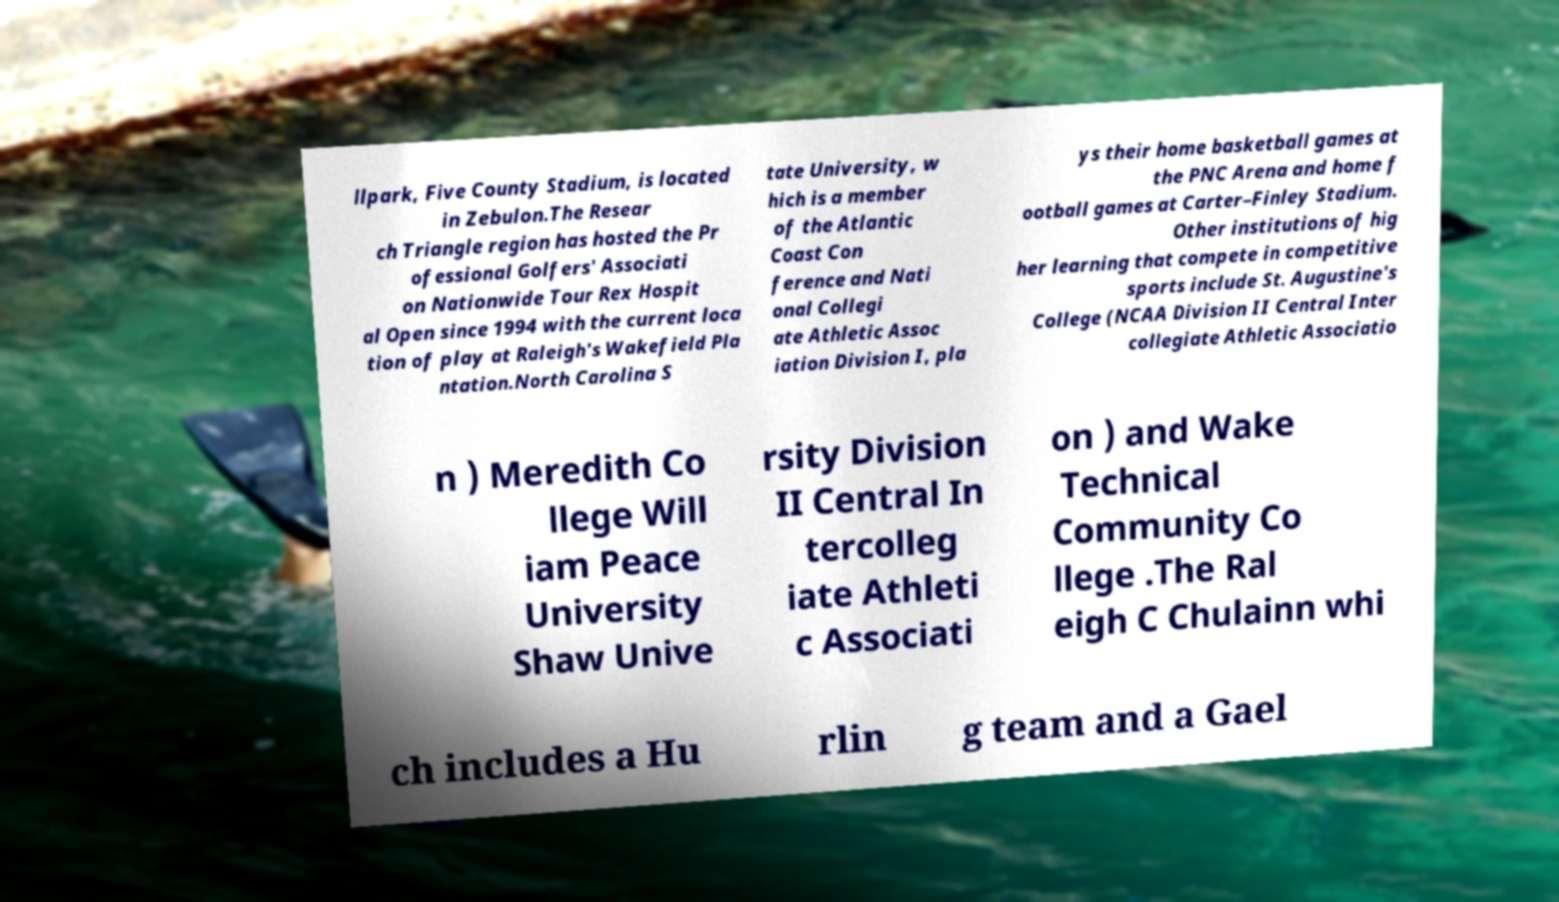For documentation purposes, I need the text within this image transcribed. Could you provide that? llpark, Five County Stadium, is located in Zebulon.The Resear ch Triangle region has hosted the Pr ofessional Golfers' Associati on Nationwide Tour Rex Hospit al Open since 1994 with the current loca tion of play at Raleigh's Wakefield Pla ntation.North Carolina S tate University, w hich is a member of the Atlantic Coast Con ference and Nati onal Collegi ate Athletic Assoc iation Division I, pla ys their home basketball games at the PNC Arena and home f ootball games at Carter–Finley Stadium. Other institutions of hig her learning that compete in competitive sports include St. Augustine's College (NCAA Division II Central Inter collegiate Athletic Associatio n ) Meredith Co llege Will iam Peace University Shaw Unive rsity Division II Central In tercolleg iate Athleti c Associati on ) and Wake Technical Community Co llege .The Ral eigh C Chulainn whi ch includes a Hu rlin g team and a Gael 